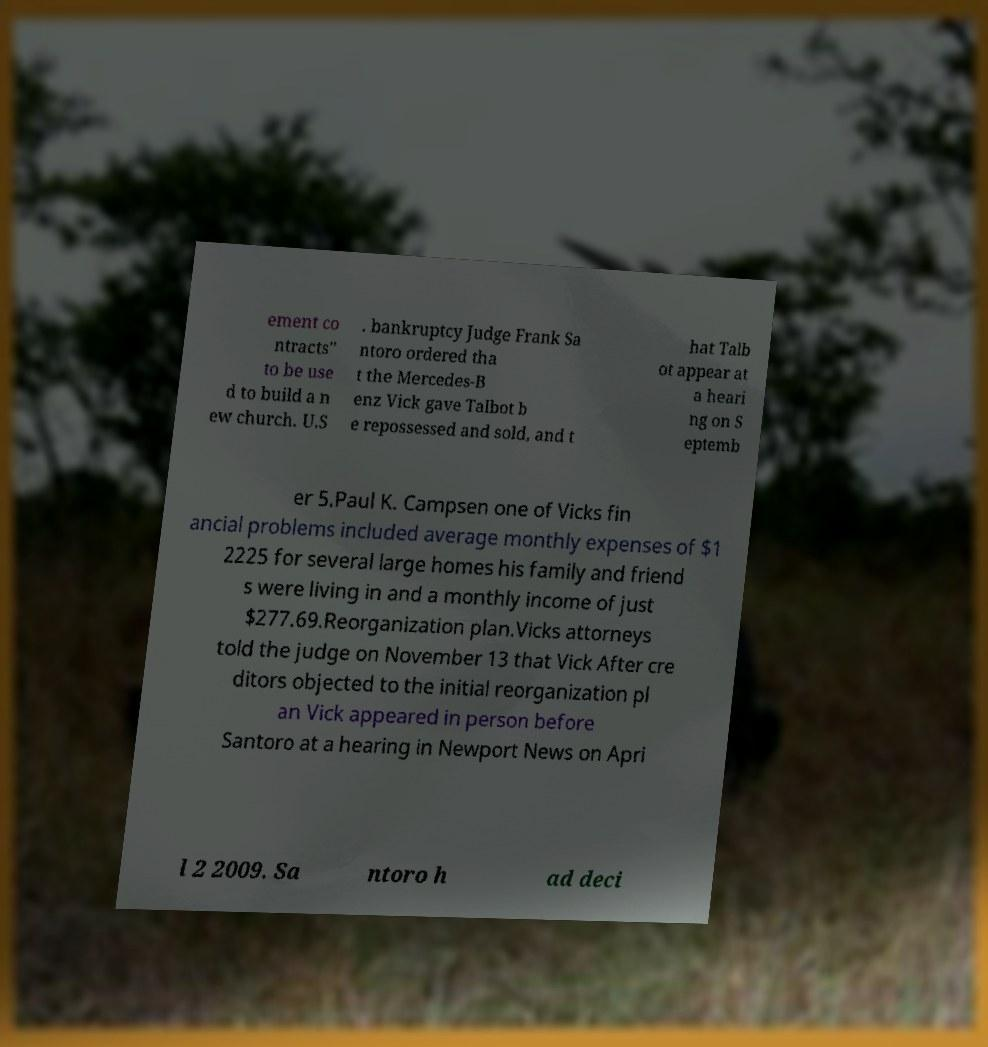What messages or text are displayed in this image? I need them in a readable, typed format. ement co ntracts" to be use d to build a n ew church. U.S . bankruptcy Judge Frank Sa ntoro ordered tha t the Mercedes-B enz Vick gave Talbot b e repossessed and sold, and t hat Talb ot appear at a heari ng on S eptemb er 5.Paul K. Campsen one of Vicks fin ancial problems included average monthly expenses of $1 2225 for several large homes his family and friend s were living in and a monthly income of just $277.69.Reorganization plan.Vicks attorneys told the judge on November 13 that Vick After cre ditors objected to the initial reorganization pl an Vick appeared in person before Santoro at a hearing in Newport News on Apri l 2 2009. Sa ntoro h ad deci 